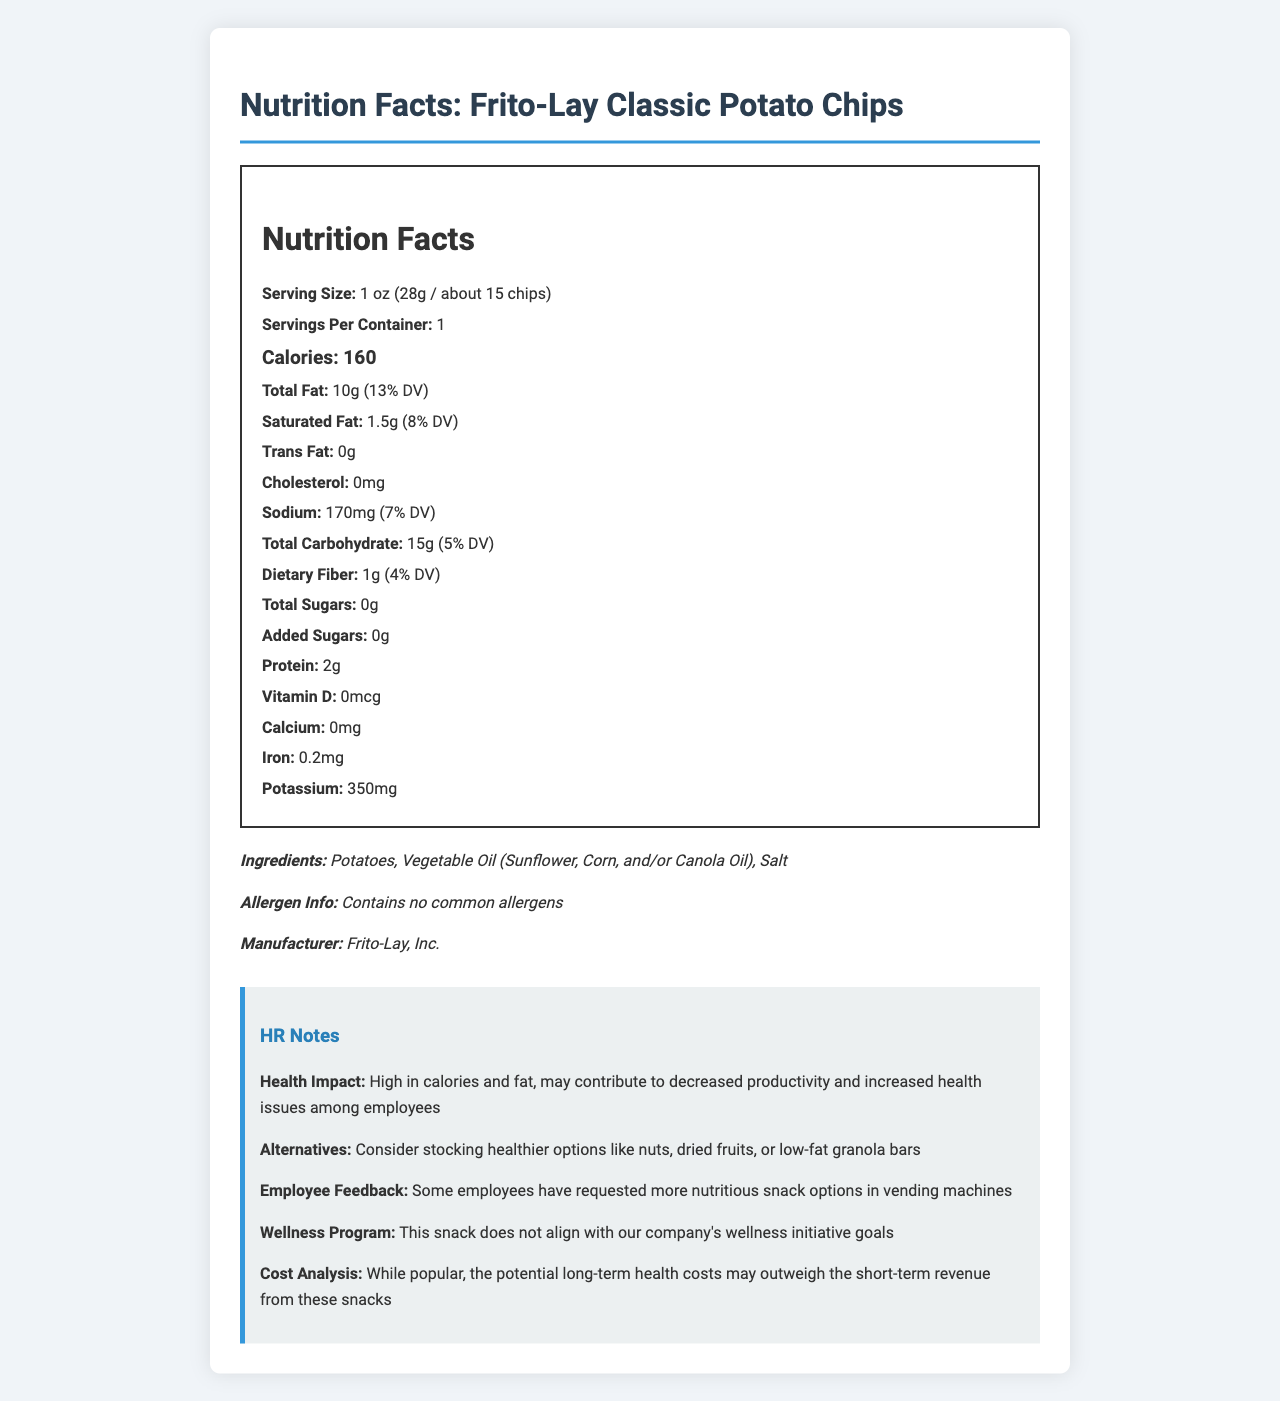How many calories are there per serving? The document states the calorie count per serving as 160.
Answer: 160 What is the serving size of the Frito-Lay Classic Potato Chips? The serving size is listed as 1 oz (28g / about 15 chips).
Answer: 1 oz (28g / about 15 chips) What is the total amount of sugars per serving? The nutrition label lists Total Sugars as 0g.
Answer: 0g What company manufactures this product? The manufacturer is mentioned in the document as Frito-Lay, Inc.
Answer: Frito-Lay, Inc. How much dietary fiber does one serving contain? The dietary fiber content per serving is listed as 1g.
Answer: 1g Is there any cholesterol in Frito-Lay Classic Potato Chips? The document states that the chips contain 0mg of cholesterol.
Answer: No/False How does the calorie content align with the company’s wellness initiative goals? According to the HR notes, the snack does not align with wellness initiative goals.
Answer: This snack does not align with our company's wellness initiative goals Which of the following ingredients is not listed in the document? A. Potatoes B. Vegetable Oil C. Salt D. Sugar Sugar is not listed as an ingredient in the document.
Answer: D What is the recommended alternative to Frito-Lay Classic Potato Chips based on HR notes? A. Soda B. Nuts C. Candy D. Ice Cream The HR notes recommend healthier options like nuts as an alternative.
Answer: B What is the employee feedback regarding snacks in the vending machine? The employee feedback mentioned is that more nutritious snack options were requested.
Answer: Some employees have requested more nutritious snack options in vending machines Are these chips a good source of essential vitamins and minerals? The document lists very minimal amounts of vitamins and minerals, so they are not a good source.
Answer: No/False What is the daily value percentage for sodium in one serving? The daily value percentage for sodium is given as 7%.
Answer: 7% Summarize the key details provided in the nutrition facts label of Frito-Lay Classic Potato Chips. Key focus details include calorie content, fat content, absence of sugars, manufacturer's information, and HR notes on health impact and recommendations.
Answer: Frito-Lay Classic Potato Chips contain 160 calories per 1 oz serving, with 10g of total fat and 0g of total sugars. The product is manufactured by Frito-Lay, Inc., and contains no common allergens. HR notes suggest that these chips do not align with wellness initiatives and recommend considering healthier alternatives. What would be the overall impact on employee productivity if these chips are frequently consumed? According to HR notes, frequent consumption may lead to decreased productivity and health issues.
Answer: High in calories and fat, may contribute to decreased productivity and increased health issues among employees What is the cost analysis insight provided in the HR notes? The HR notes suggest that long-term health costs could outweigh the short-term revenue gains.
Answer: While popular, the potential long-term health costs may outweigh the short-term revenue from these snacks 